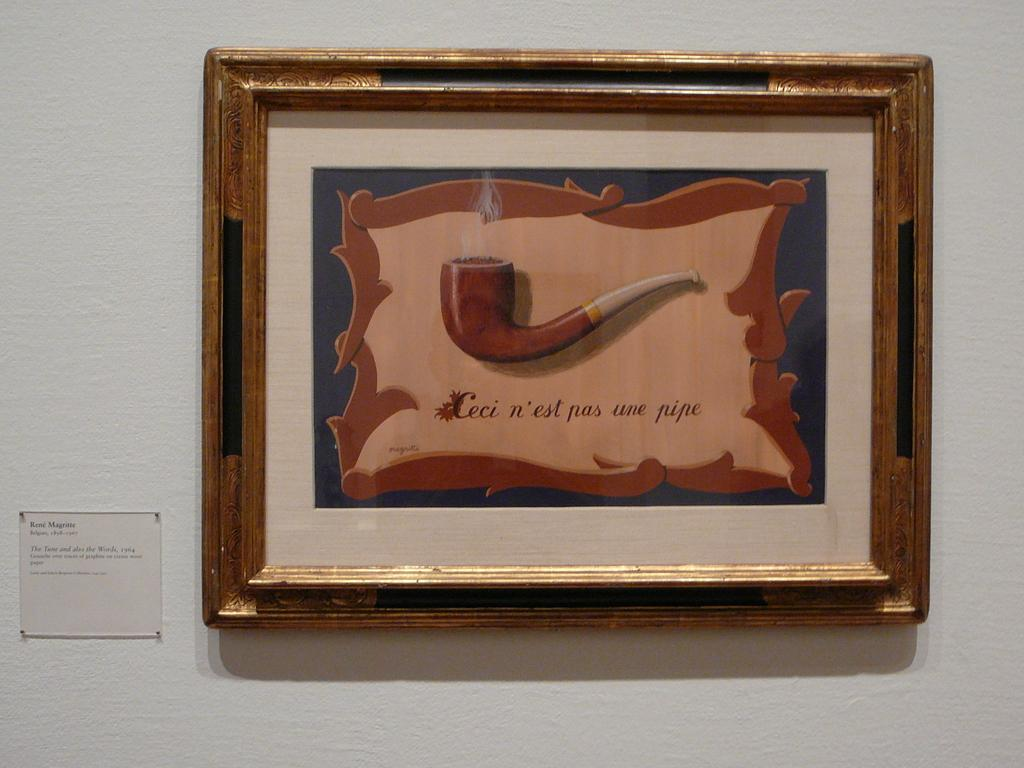<image>
Describe the image concisely. A framed painting of a pipe says "Ceci n'est pas une pipe". 